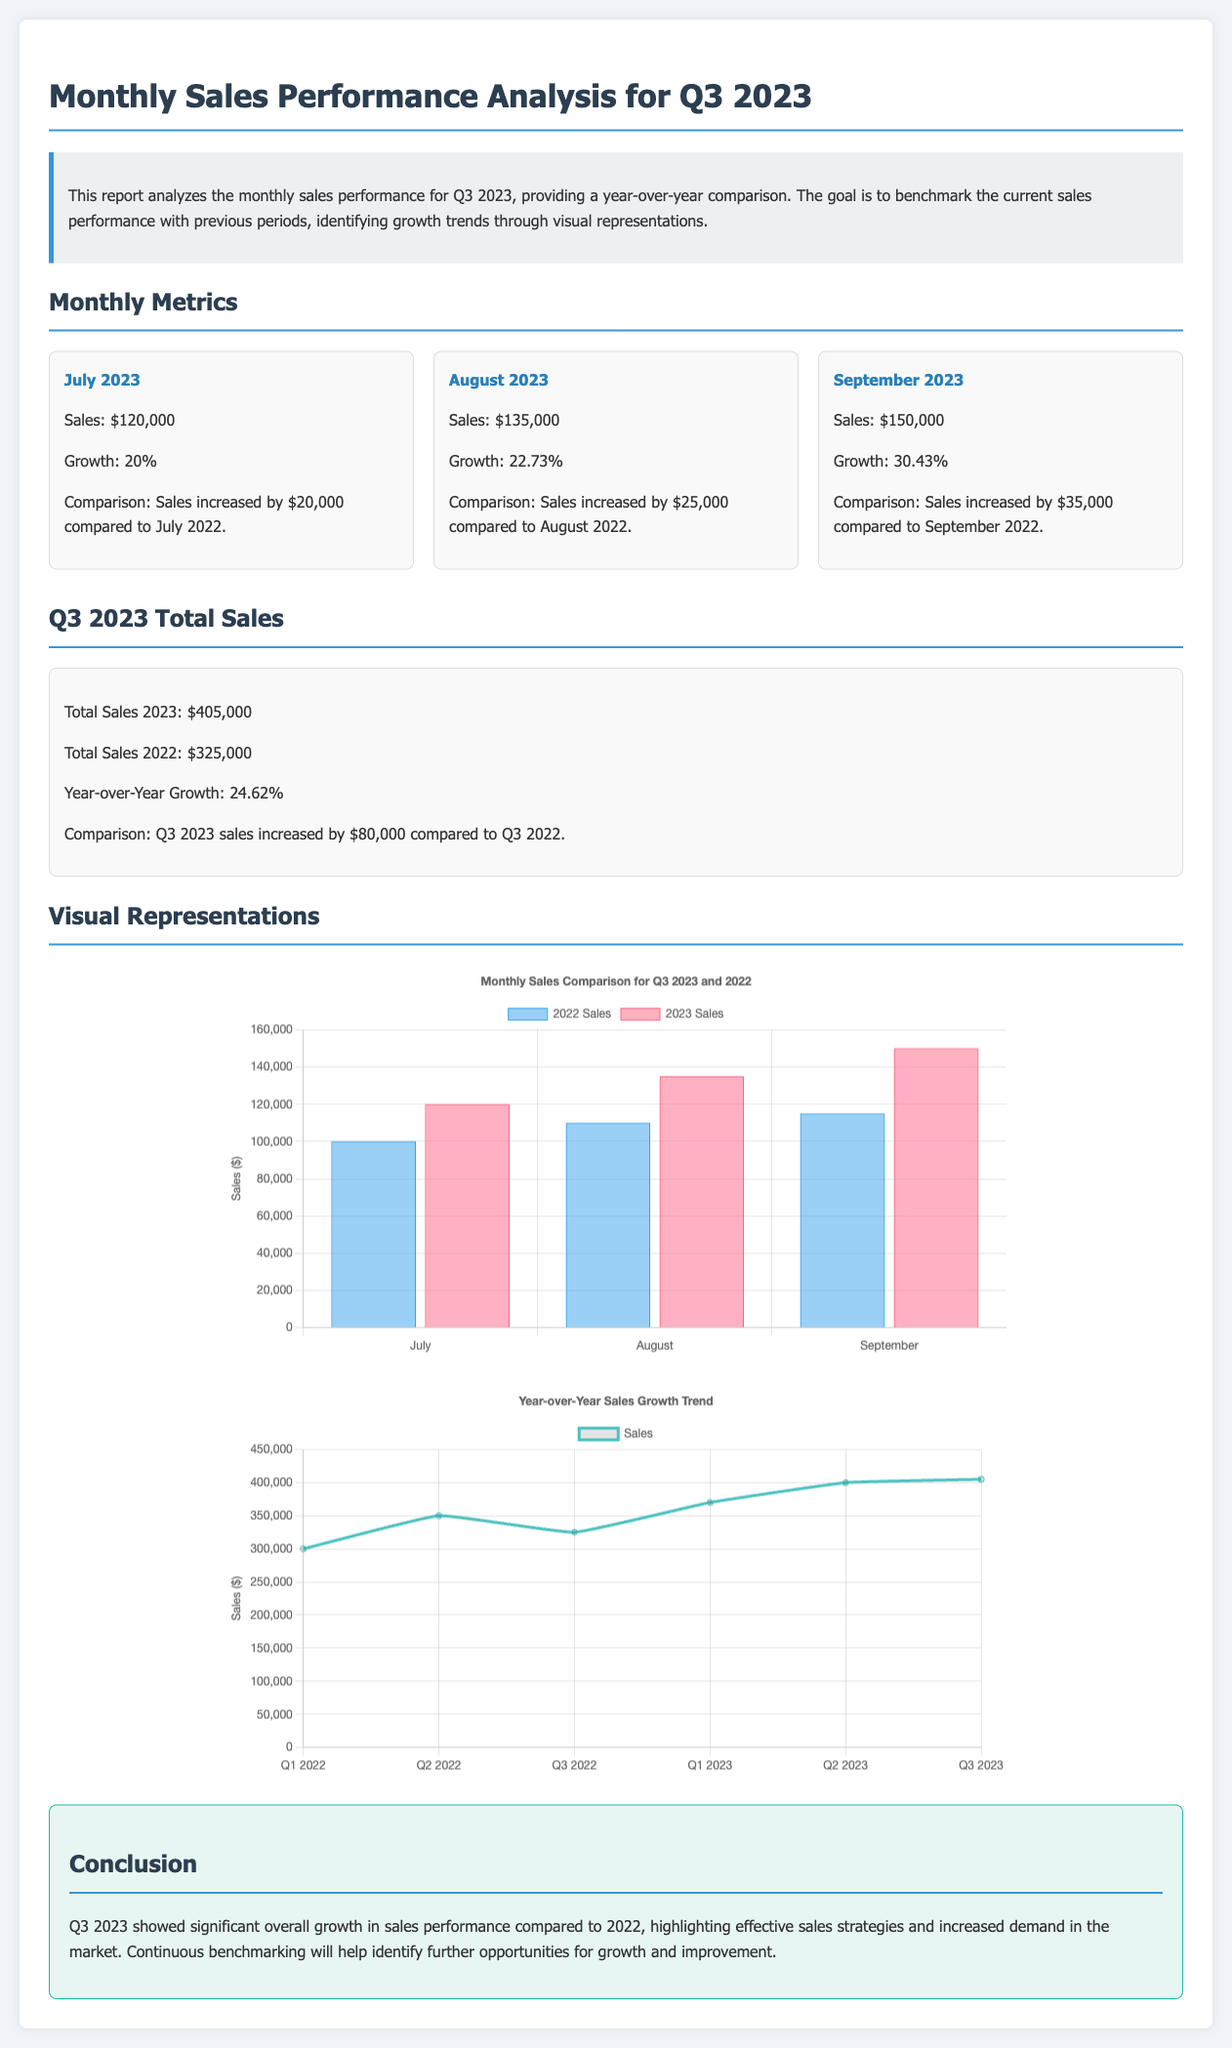What were the total sales in July 2023? The total sales for July 2023 is explicitly stated in the document as $120,000.
Answer: $120,000 What was the year-over-year growth for Q3 2023? The document provides the year-over-year growth for Q3 2023, which is 24.62%.
Answer: 24.62% How much did sales increase in September 2023 compared to September 2022? The document indicates that sales increased by $35,000 when comparing September 2023 to September 2022.
Answer: $35,000 What was the total sales figure for Q3 2022? The document states that total sales for Q3 2022 was $325,000.
Answer: $325,000 What is the growth percentage for August 2023? The document reveals that the growth percentage for August 2023 is 22.73%.
Answer: 22.73% How many months are analyzed in this report? The report assesses sales performance over three months: July, August, and September.
Answer: Three months What chart type is used for the sales comparison in Q3 2023? The document states that a bar chart is used to visualize monthly sales comparison.
Answer: Bar chart What color represents 2023 sales in the monthly sales comparison chart? The document specifies that 2023 sales are represented in red (rgba(255, 99, 132, 0.5)).
Answer: Red Which month had the highest sales figure in Q3 2023? The data indicates that September 2023 had the highest sales figure at $150,000.
Answer: September 2023 